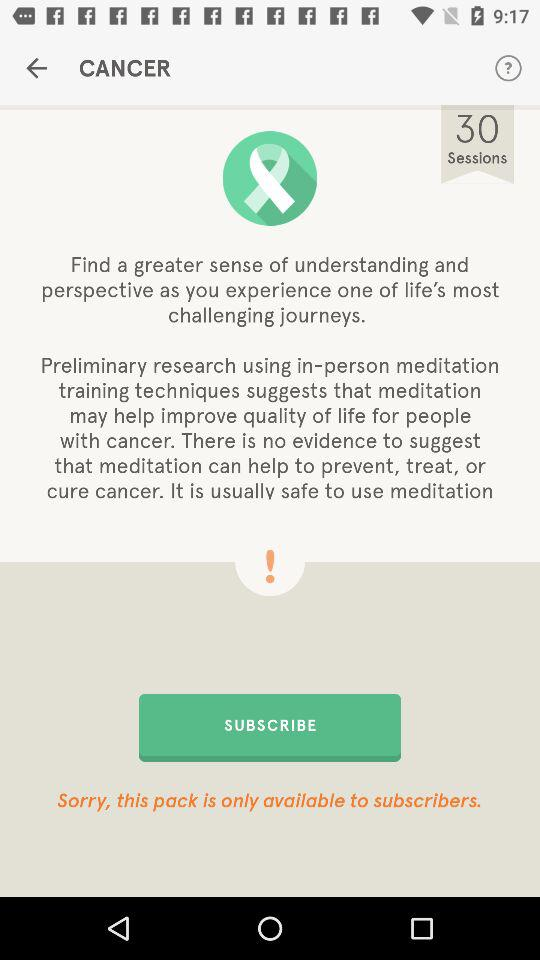How much does it cost to subscribe?
When the provided information is insufficient, respond with <no answer>. <no answer> 